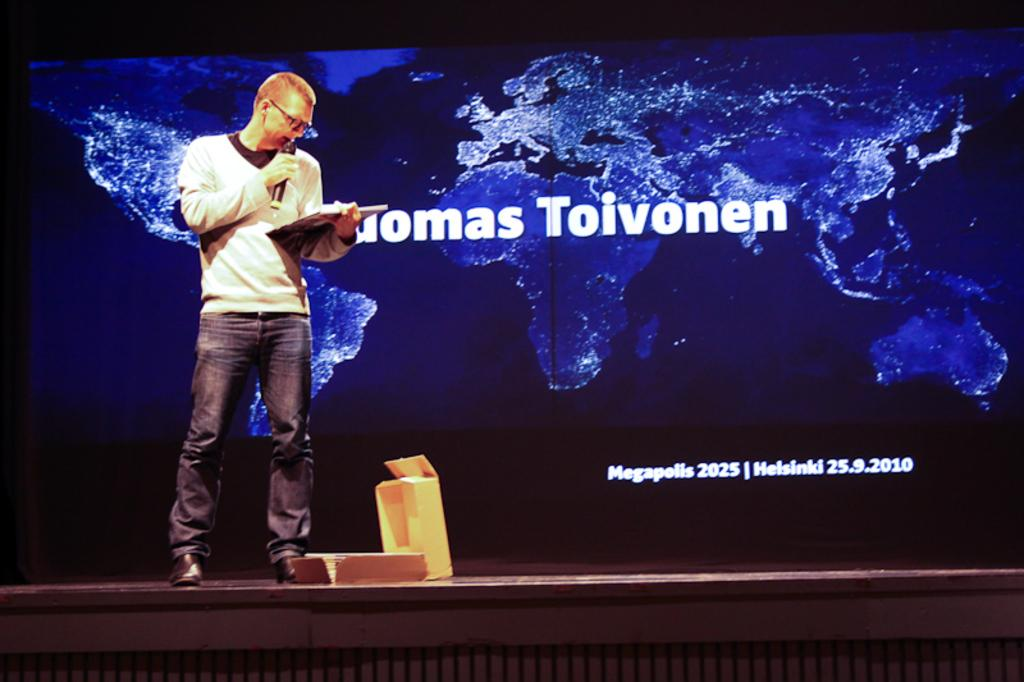<image>
Write a terse but informative summary of the picture. A man stands reading a book on a stage with a partially revelled name "..omas Toivonen" on a screen behind him and written below that is: "Megapolis 2025 Helsinki 25.9.2010" 